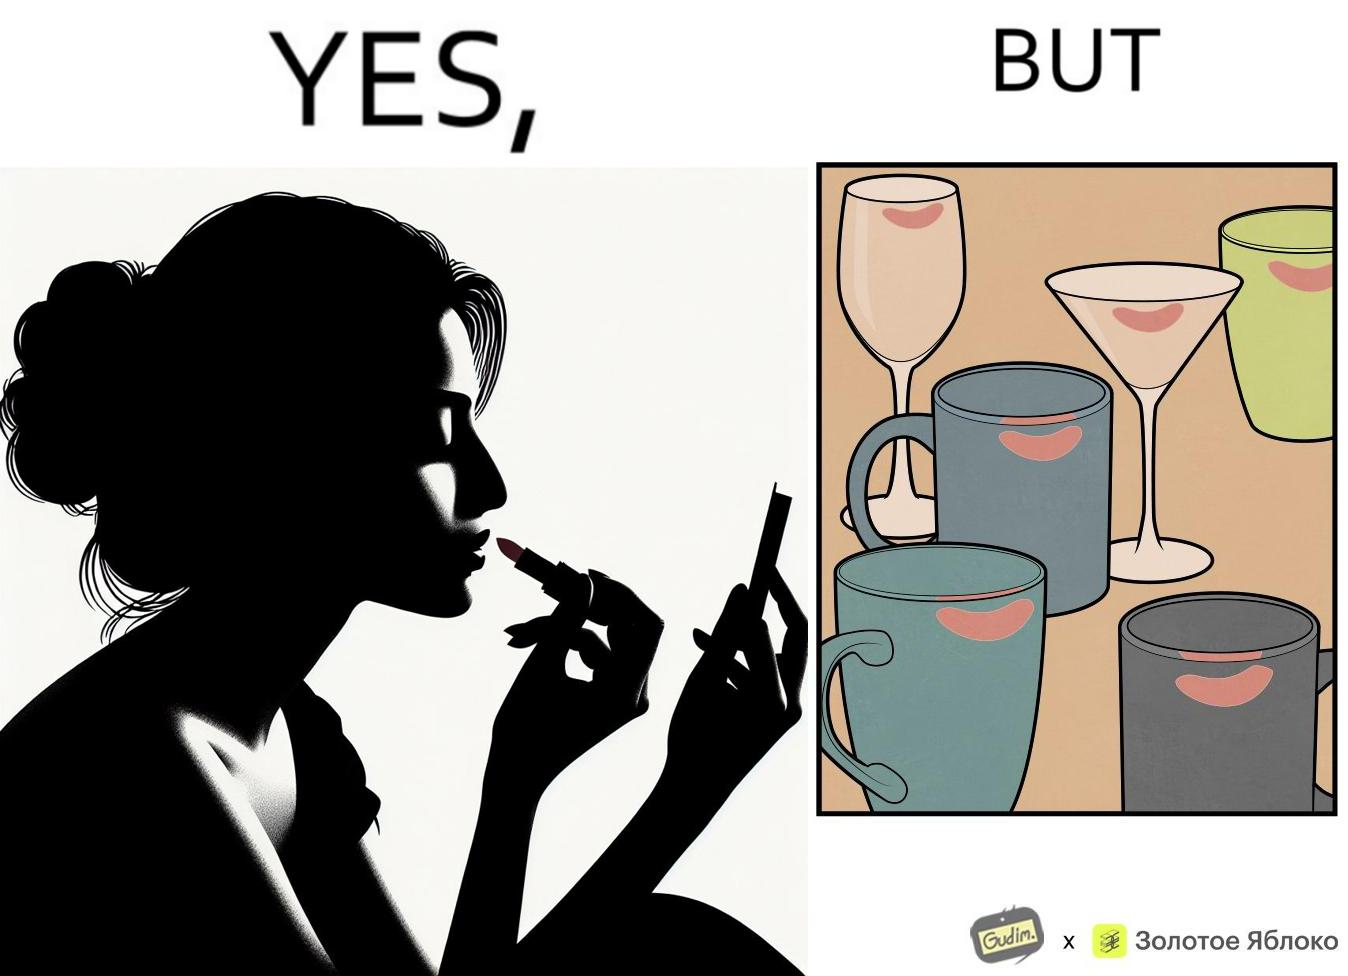Does this image contain satire or humor? Yes, this image is satirical. 